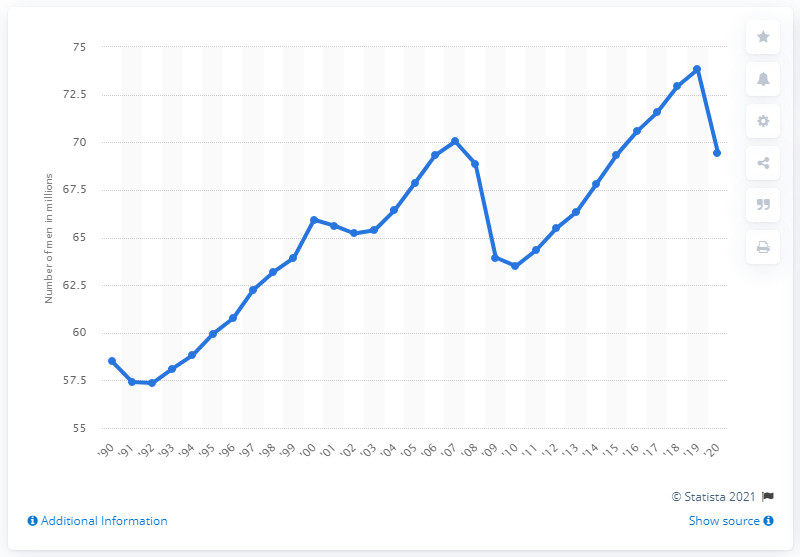Outline some significant characteristics in this image. In 2020, there were approximately 69,460 full-time men employed in the United States. 